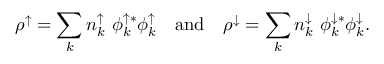Convert formula to latex. <formula><loc_0><loc_0><loc_500><loc_500>\rho ^ { \uparrow } = \sum _ { k } { n _ { k } ^ { \uparrow } \ \phi _ { k } ^ { \uparrow * } \phi _ { k } ^ { \uparrow } } \quad a n d \quad \rho ^ { \downarrow } = \sum _ { k } { n _ { k } ^ { \downarrow } \ \phi _ { k } ^ { \downarrow * } \phi _ { k } ^ { \downarrow } } .</formula> 